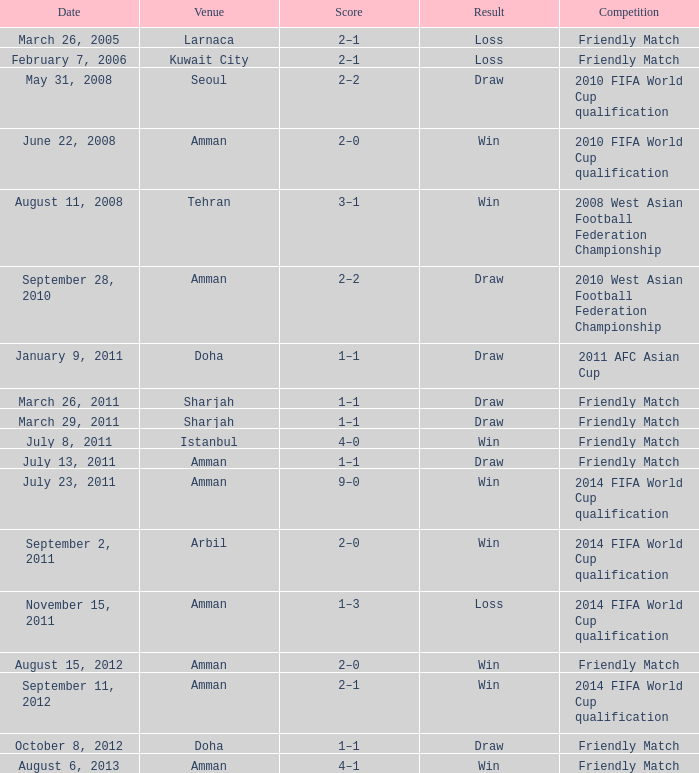What was the designation of the event occurring on may 31, 2008? 2010 FIFA World Cup qualification. 